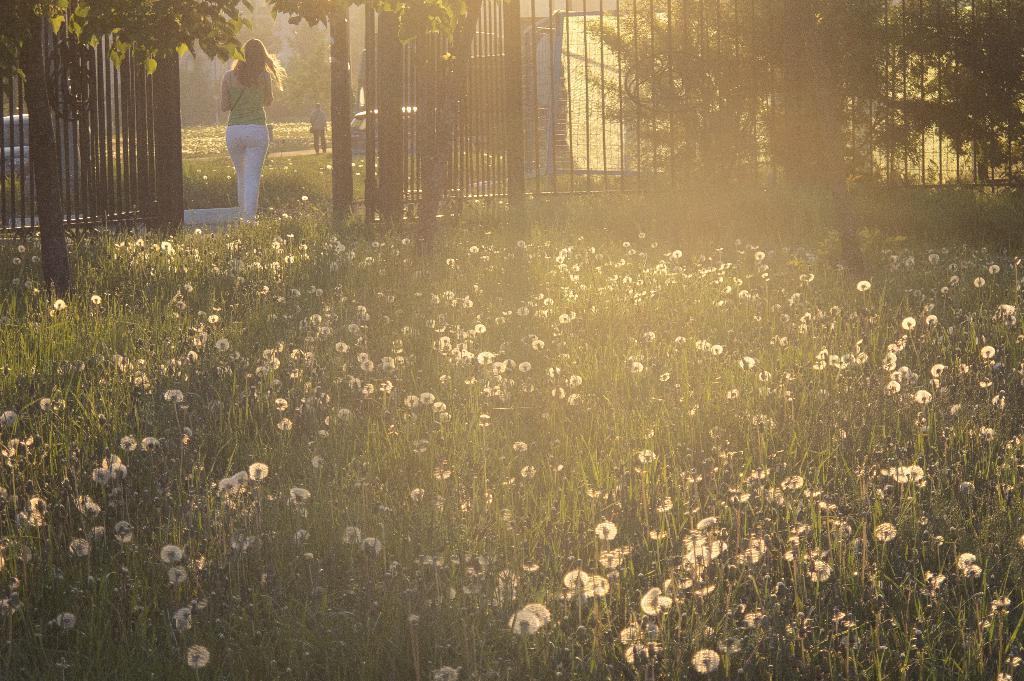How would you summarize this image in a sentence or two? There are some plants with flowers at the bottom of this image. there are two persons standing at the top left side of this image. There are some trees and a fencing at the top of this image. 